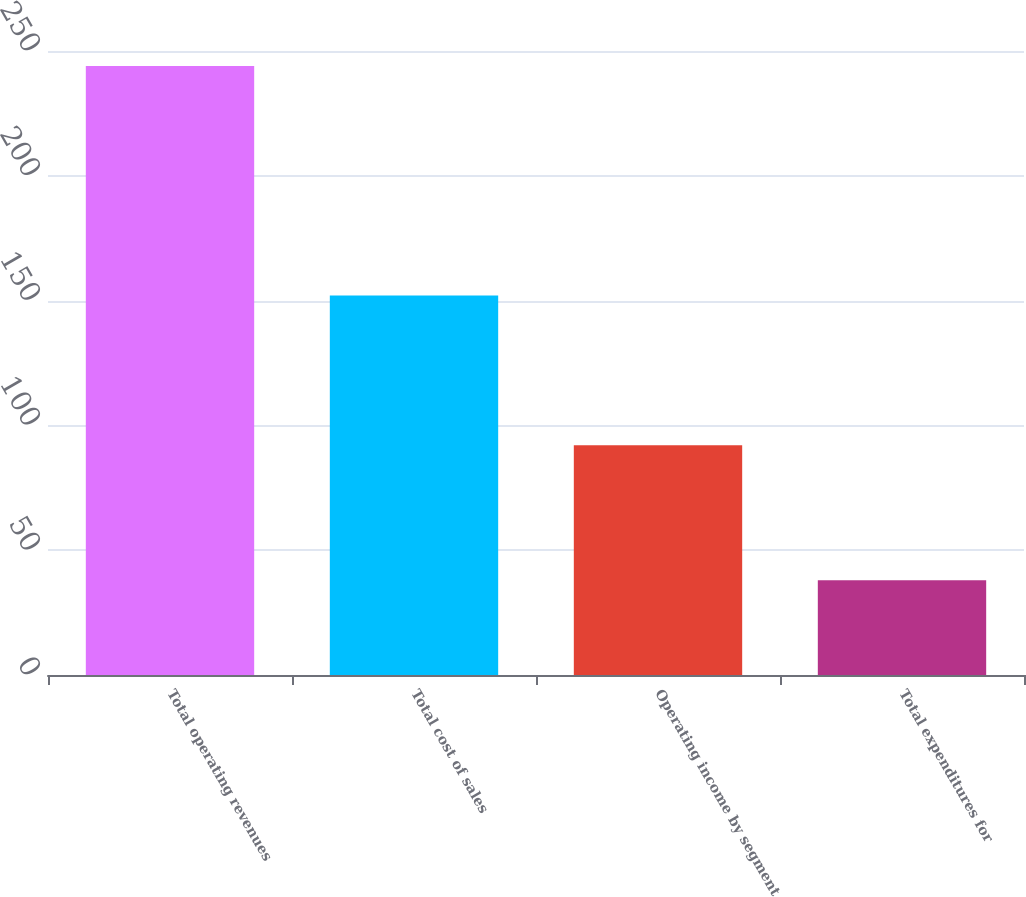<chart> <loc_0><loc_0><loc_500><loc_500><bar_chart><fcel>Total operating revenues<fcel>Total cost of sales<fcel>Operating income by segment<fcel>Total expenditures for<nl><fcel>244<fcel>152<fcel>92<fcel>38<nl></chart> 